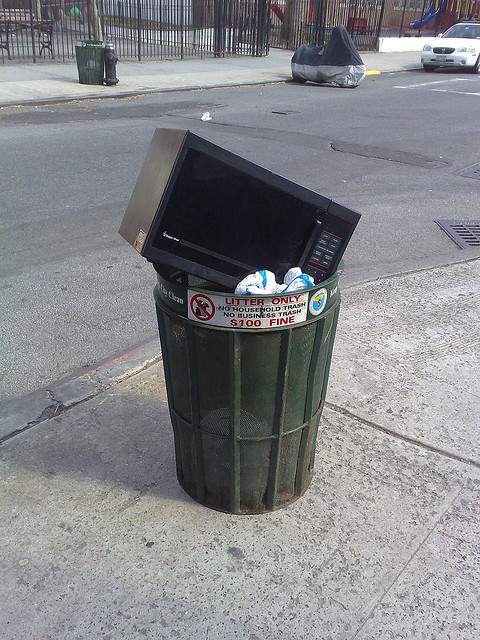Please extract the text content from this image. FINE ONLY LITTER BUSINESS NO S TRASH TRASH HOUSEHOLD NO $100 